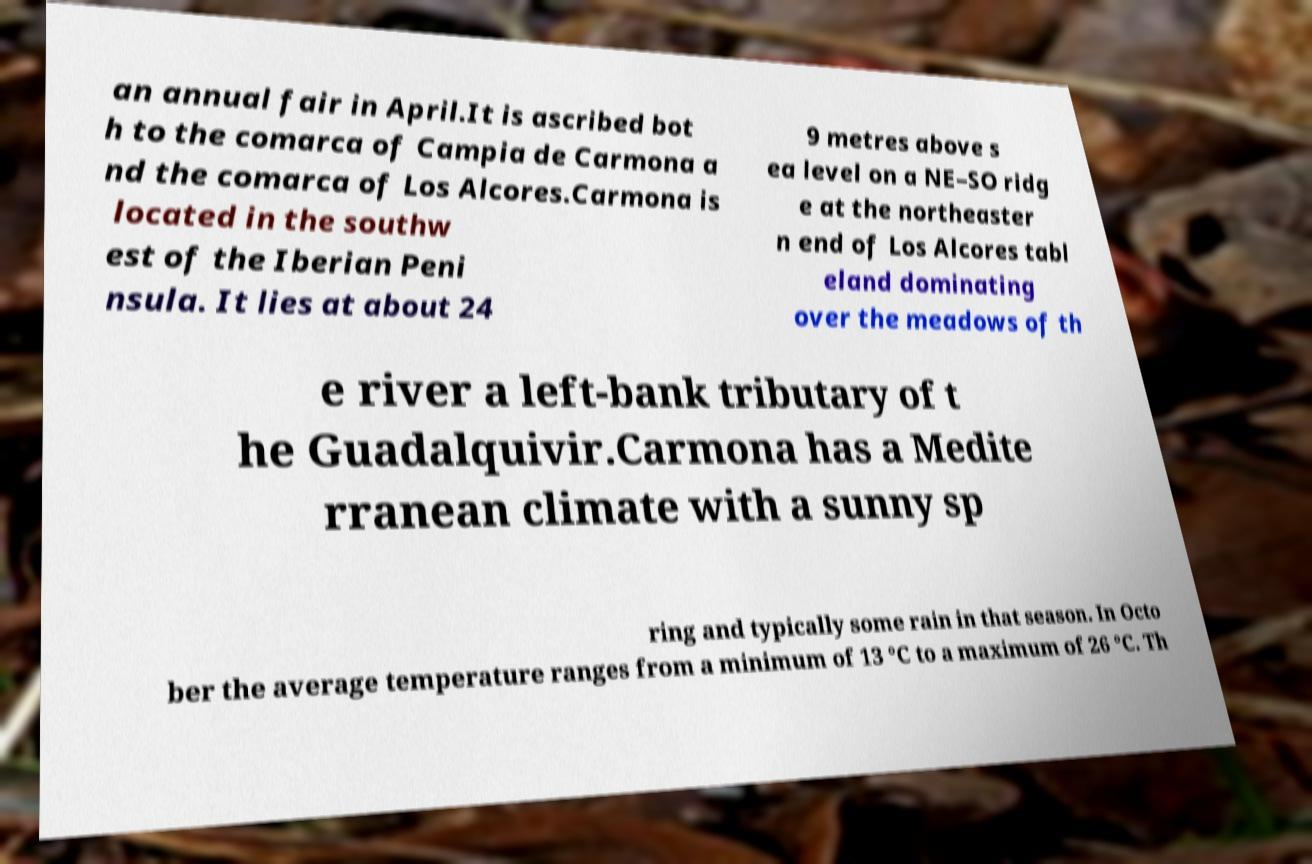Could you extract and type out the text from this image? an annual fair in April.It is ascribed bot h to the comarca of Campia de Carmona a nd the comarca of Los Alcores.Carmona is located in the southw est of the Iberian Peni nsula. It lies at about 24 9 metres above s ea level on a NE–SO ridg e at the northeaster n end of Los Alcores tabl eland dominating over the meadows of th e river a left-bank tributary of t he Guadalquivir.Carmona has a Medite rranean climate with a sunny sp ring and typically some rain in that season. In Octo ber the average temperature ranges from a minimum of 13 °C to a maximum of 26 °C. Th 